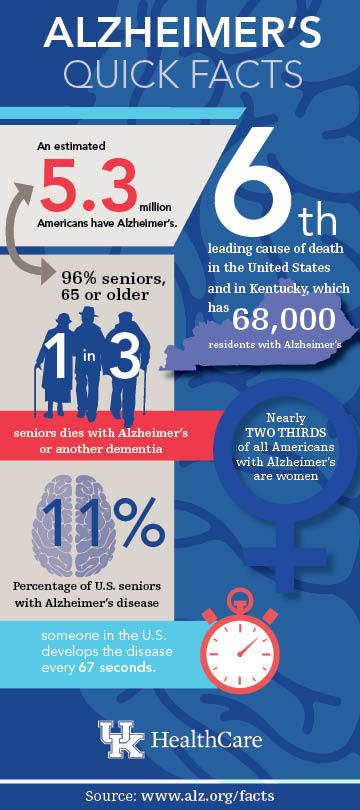List a handful of essential elements in this visual. According to recent statistics, a significant portion of U.S. seniors, approximately 89%, are not affected by Alzheimer's disease. According to statistics, there are approximately 68,000 residents in the United States and the state of Kentucky who are affected by Alzheimer's disease. The color of the clock dial is white. According to the data, approximately 5.3 million people were affected, and of that number, 96% were 65 years old or older. Approximately two Americans develop Alzheimer's disease every 2 minutes. 